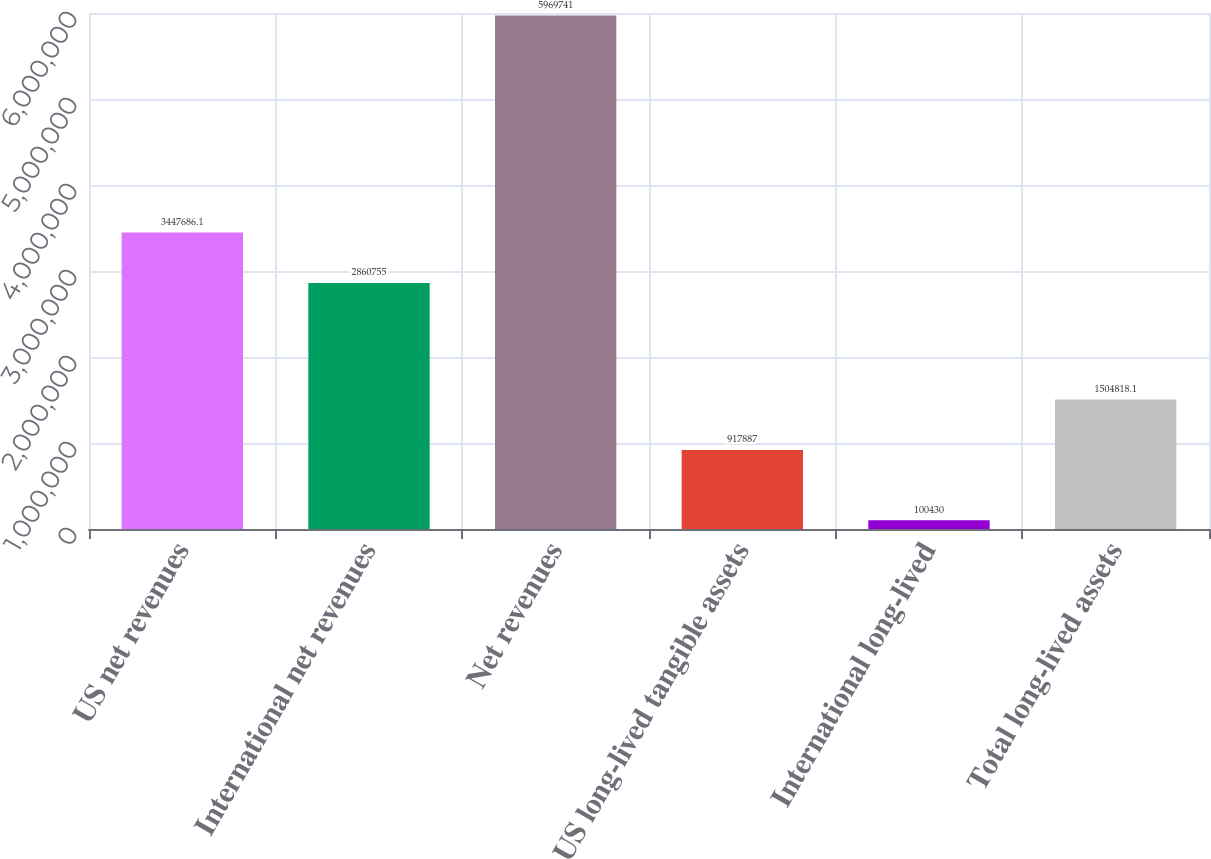Convert chart to OTSL. <chart><loc_0><loc_0><loc_500><loc_500><bar_chart><fcel>US net revenues<fcel>International net revenues<fcel>Net revenues<fcel>US long-lived tangible assets<fcel>International long-lived<fcel>Total long-lived assets<nl><fcel>3.44769e+06<fcel>2.86076e+06<fcel>5.96974e+06<fcel>917887<fcel>100430<fcel>1.50482e+06<nl></chart> 